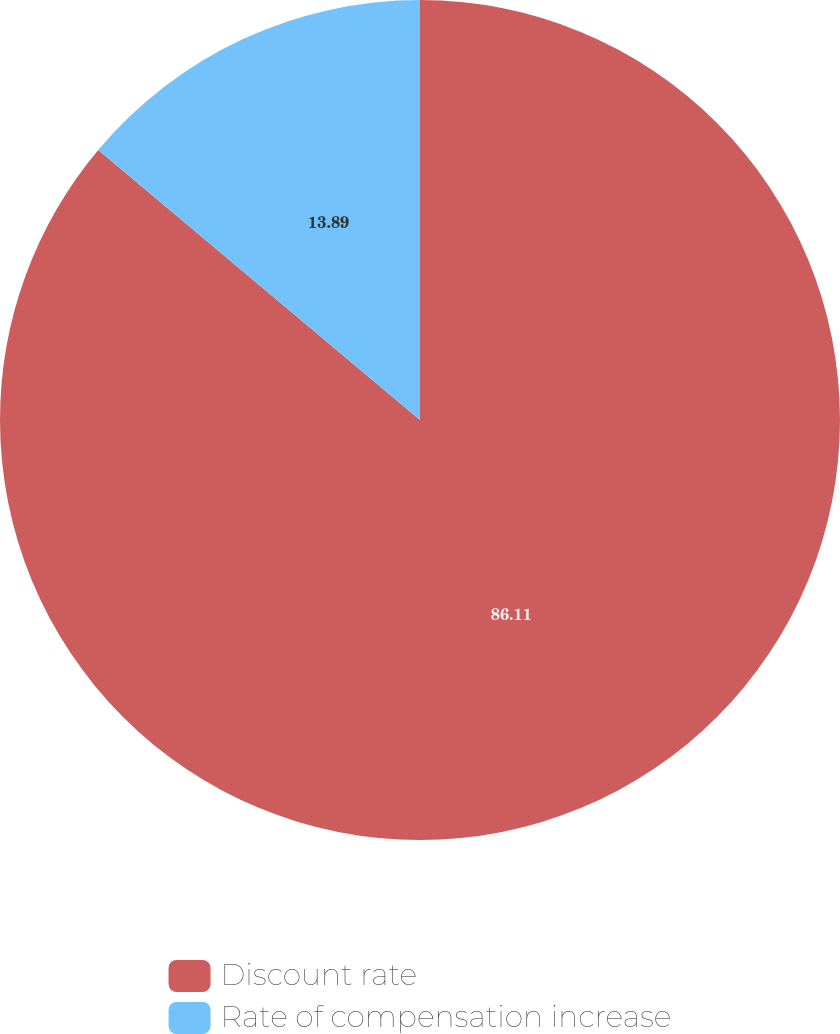Convert chart to OTSL. <chart><loc_0><loc_0><loc_500><loc_500><pie_chart><fcel>Discount rate<fcel>Rate of compensation increase<nl><fcel>86.11%<fcel>13.89%<nl></chart> 